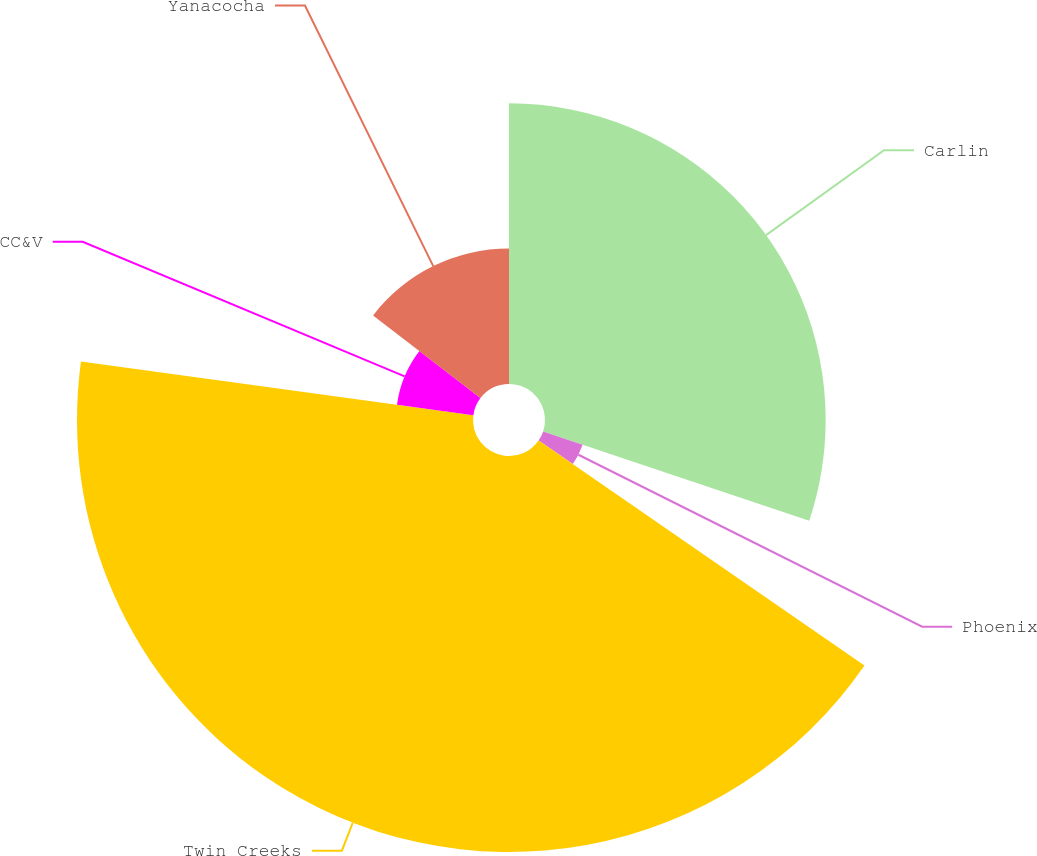Convert chart. <chart><loc_0><loc_0><loc_500><loc_500><pie_chart><fcel>Carlin<fcel>Phoenix<fcel>Twin Creeks<fcel>CC&V<fcel>Yanacocha<nl><fcel>30.15%<fcel>4.47%<fcel>42.54%<fcel>8.28%<fcel>14.56%<nl></chart> 